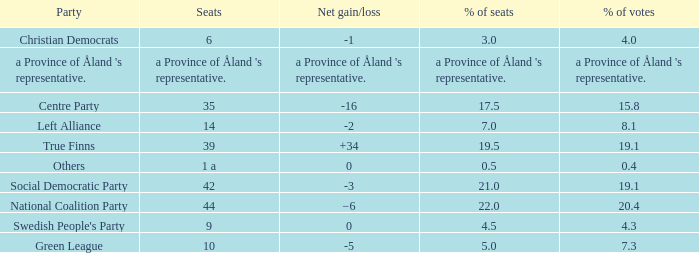Regarding the seats that casted 8.1% of the vote how many seats were held? 14.0. 